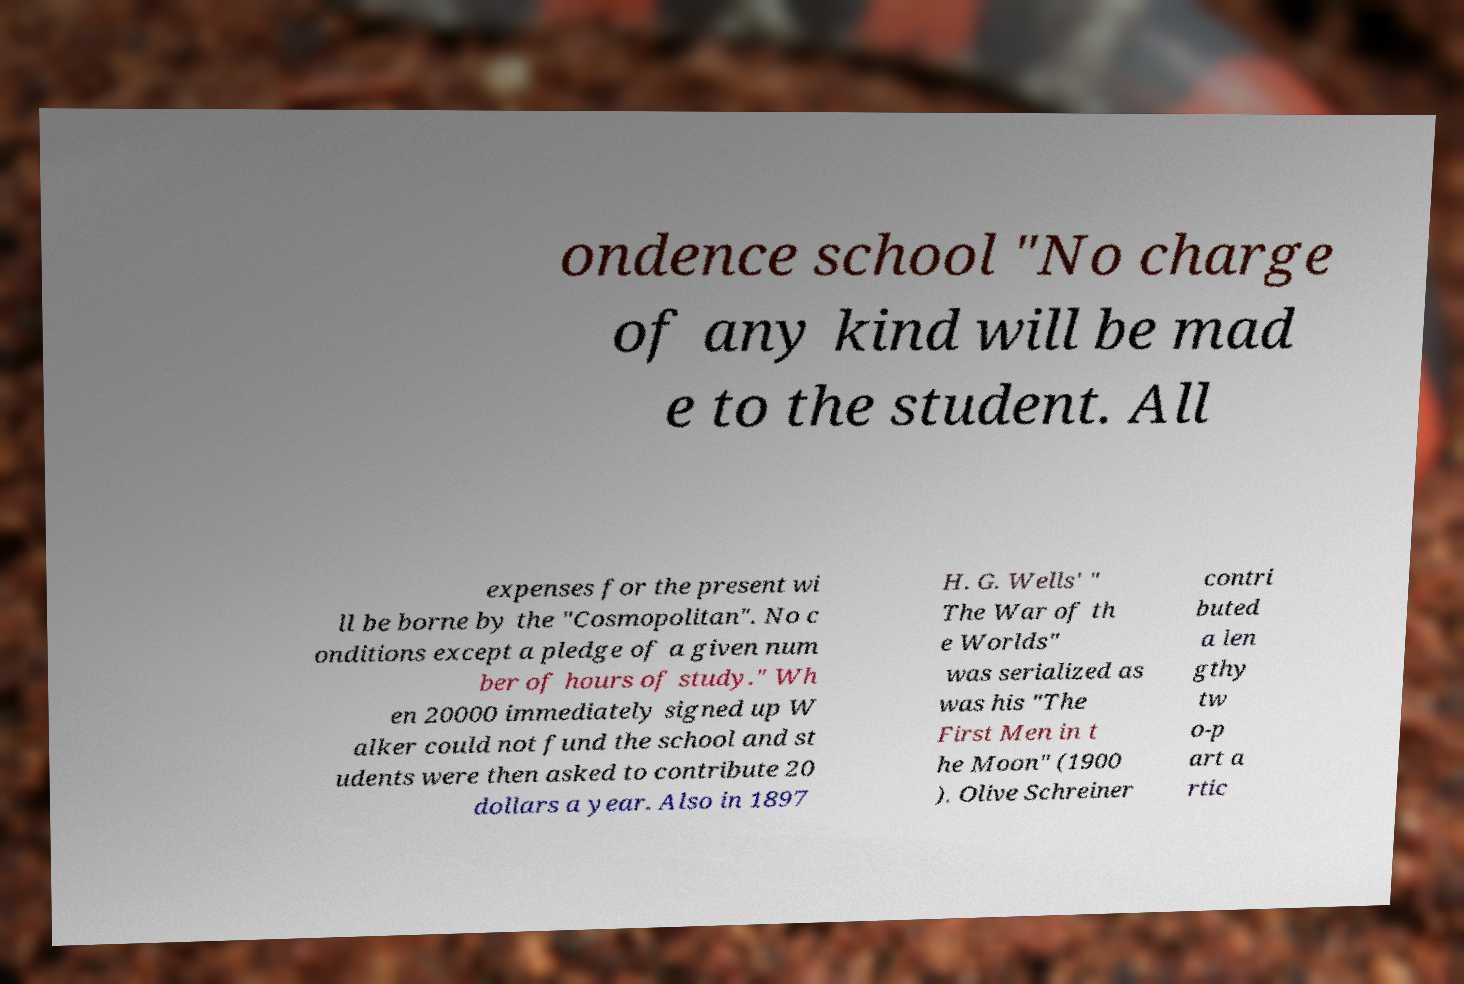Please read and relay the text visible in this image. What does it say? ondence school "No charge of any kind will be mad e to the student. All expenses for the present wi ll be borne by the "Cosmopolitan". No c onditions except a pledge of a given num ber of hours of study." Wh en 20000 immediately signed up W alker could not fund the school and st udents were then asked to contribute 20 dollars a year. Also in 1897 H. G. Wells' " The War of th e Worlds" was serialized as was his "The First Men in t he Moon" (1900 ). Olive Schreiner contri buted a len gthy tw o-p art a rtic 